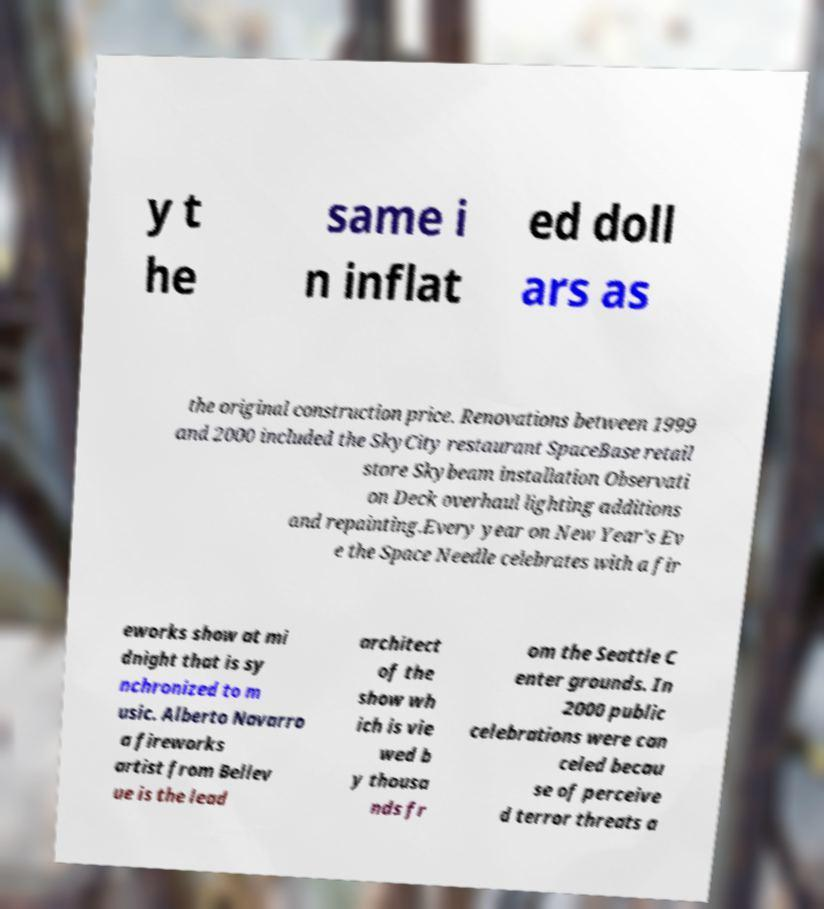Could you extract and type out the text from this image? y t he same i n inflat ed doll ars as the original construction price. Renovations between 1999 and 2000 included the SkyCity restaurant SpaceBase retail store Skybeam installation Observati on Deck overhaul lighting additions and repainting.Every year on New Year's Ev e the Space Needle celebrates with a fir eworks show at mi dnight that is sy nchronized to m usic. Alberto Navarro a fireworks artist from Bellev ue is the lead architect of the show wh ich is vie wed b y thousa nds fr om the Seattle C enter grounds. In 2000 public celebrations were can celed becau se of perceive d terror threats a 